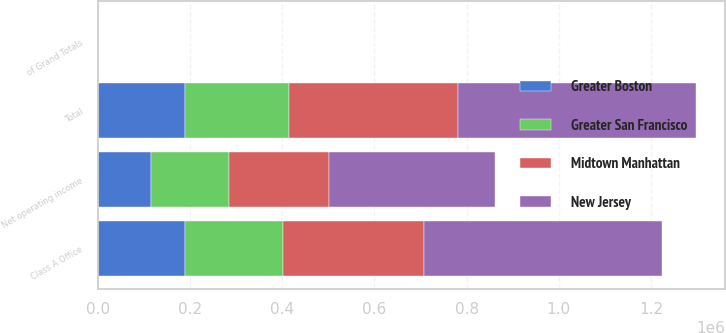<chart> <loc_0><loc_0><loc_500><loc_500><stacked_bar_chart><ecel><fcel>Class A Office<fcel>Total<fcel>of Grand Totals<fcel>Net operating income<nl><fcel>Midtown Manhattan<fcel>305576<fcel>365563<fcel>26.86<fcel>216774<nl><fcel>Greater San Francisco<fcel>214245<fcel>227440<fcel>16.71<fcel>168545<nl><fcel>New Jersey<fcel>515401<fcel>515401<fcel>37.87<fcel>360444<nl><fcel>Greater Boston<fcel>188009<fcel>188009<fcel>13.81<fcel>116200<nl></chart> 